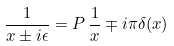Convert formula to latex. <formula><loc_0><loc_0><loc_500><loc_500>\frac { 1 } { x \pm i \epsilon } = P \, \frac { 1 } { x } \mp i \pi \delta ( x )</formula> 